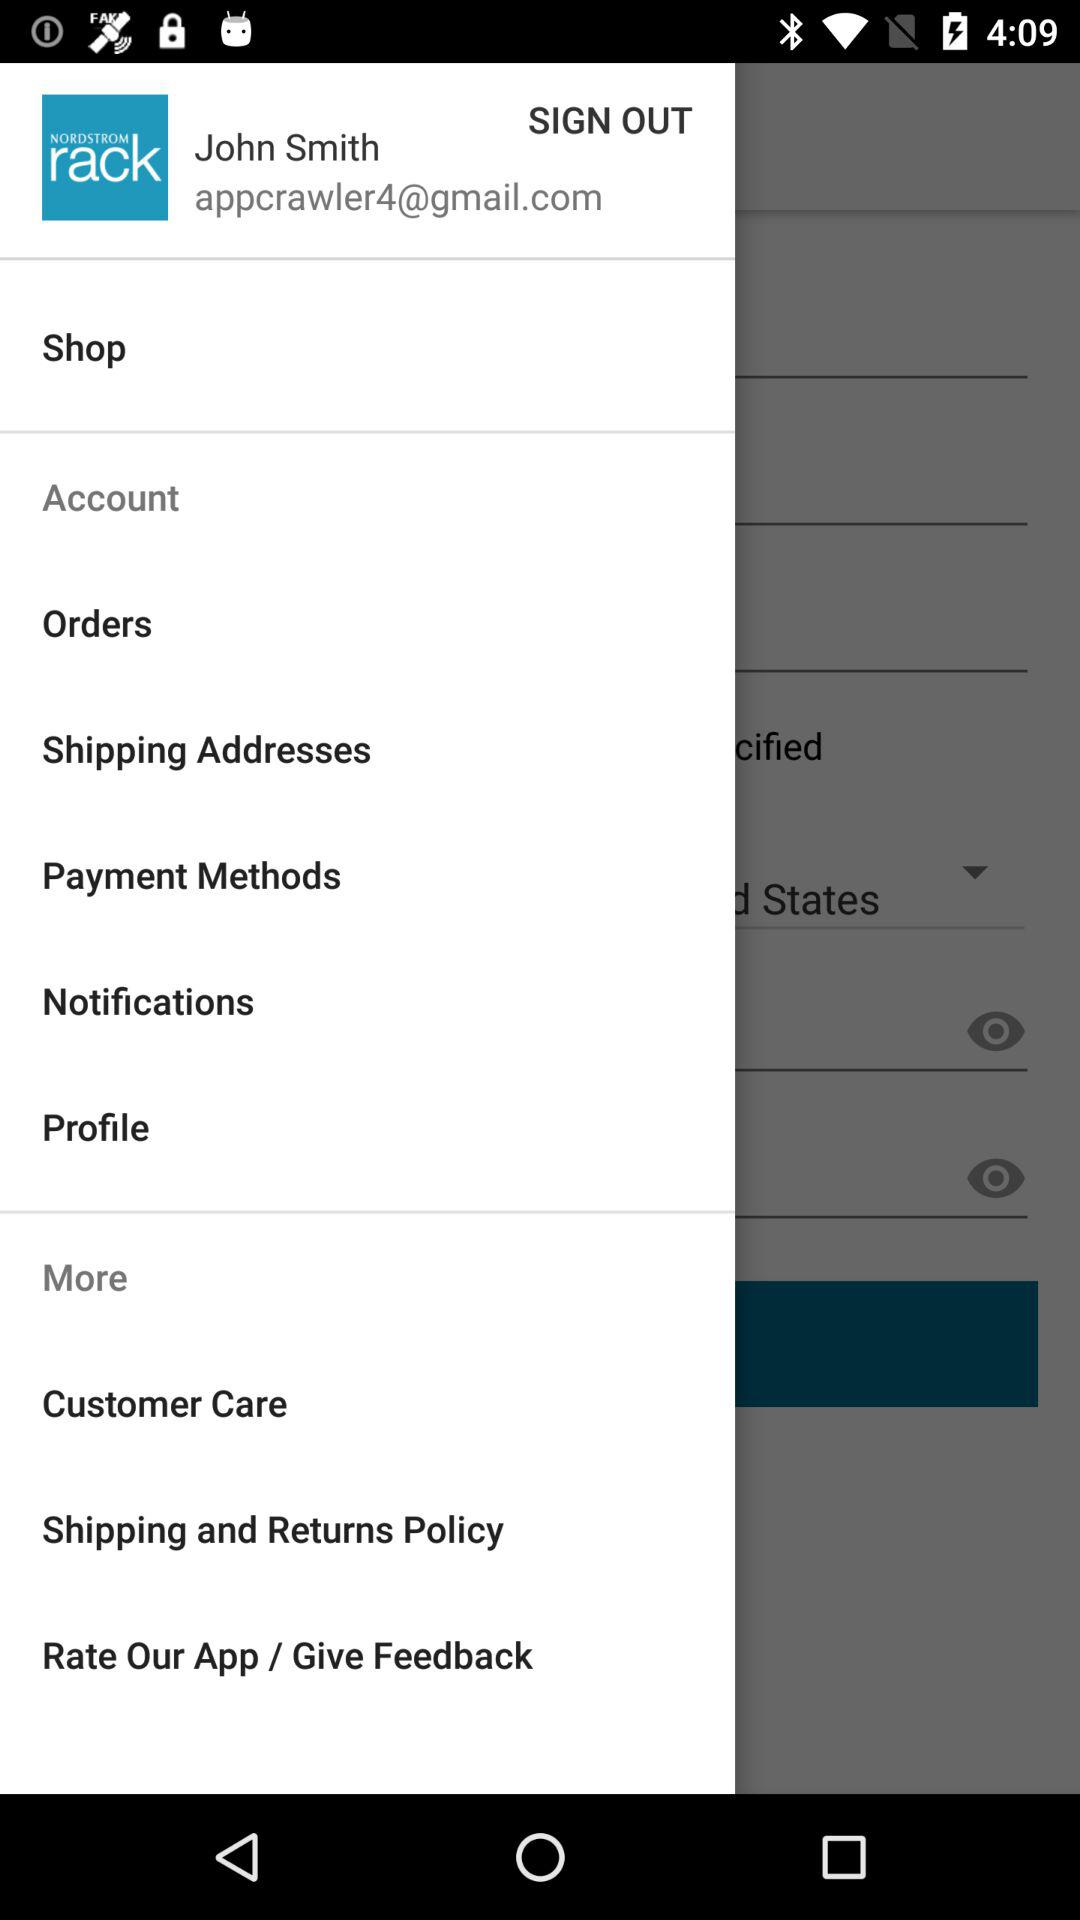What is the email address of the user? The email address of the user is appcrawler4@gmail.com. 